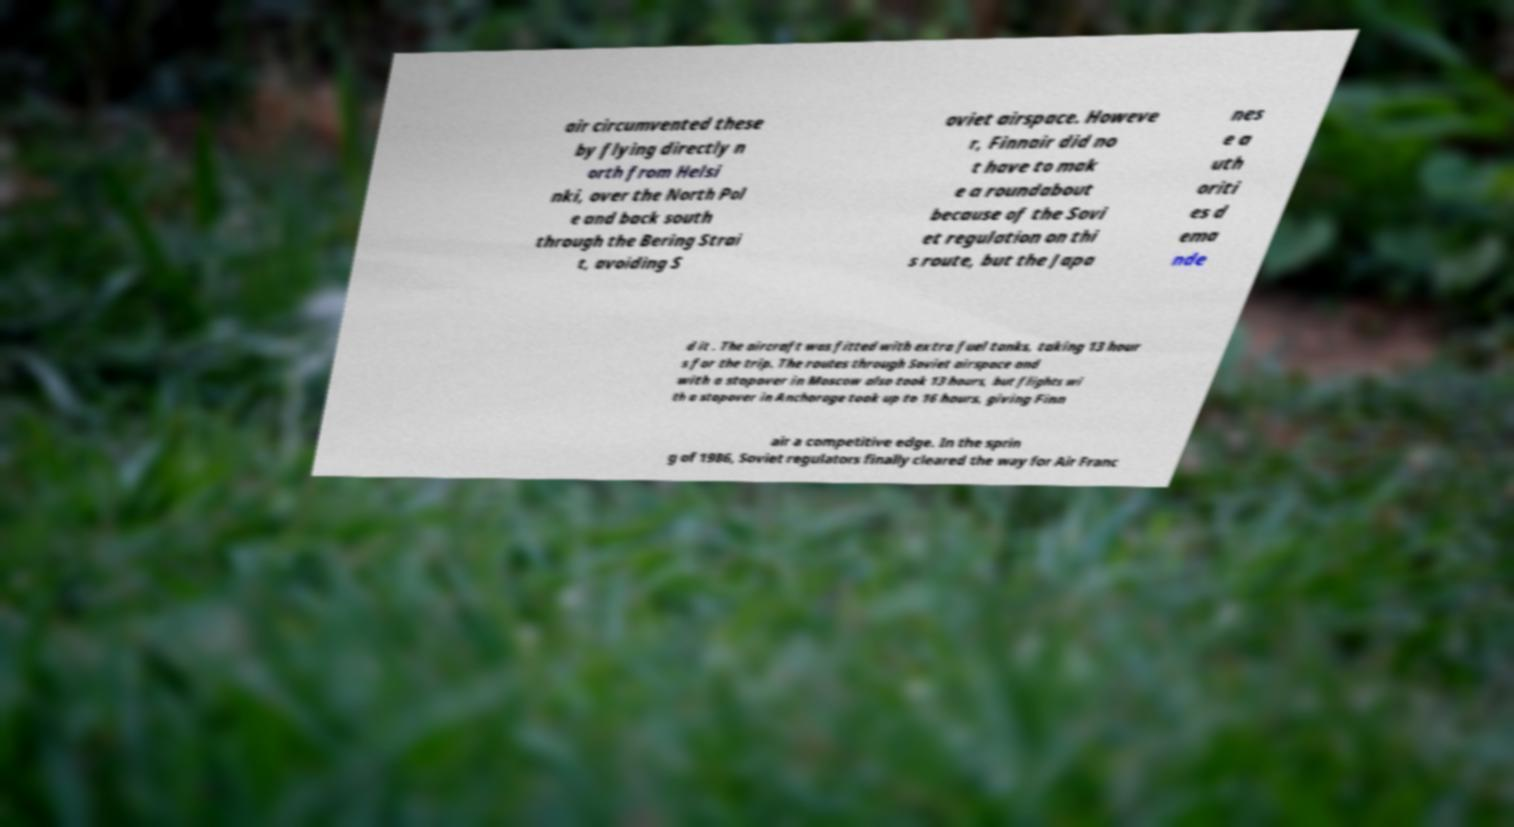Can you accurately transcribe the text from the provided image for me? air circumvented these by flying directly n orth from Helsi nki, over the North Pol e and back south through the Bering Strai t, avoiding S oviet airspace. Howeve r, Finnair did no t have to mak e a roundabout because of the Sovi et regulation on thi s route, but the Japa nes e a uth oriti es d ema nde d it . The aircraft was fitted with extra fuel tanks, taking 13 hour s for the trip. The routes through Soviet airspace and with a stopover in Moscow also took 13 hours, but flights wi th a stopover in Anchorage took up to 16 hours, giving Finn air a competitive edge. In the sprin g of 1986, Soviet regulators finally cleared the way for Air Franc 